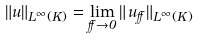Convert formula to latex. <formula><loc_0><loc_0><loc_500><loc_500>\| u \| _ { L ^ { \infty } ( K ) } = \lim _ { \alpha \to 0 } \| \, u _ { \alpha } \| _ { L ^ { \infty } ( K ) }</formula> 